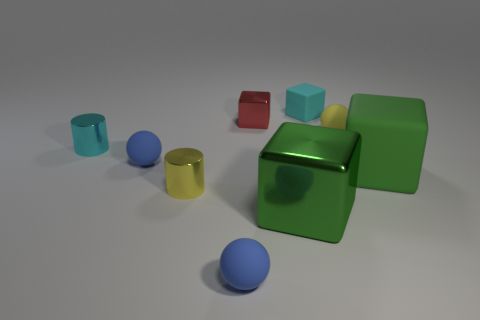Subtract all small blue matte spheres. How many spheres are left? 1 Add 1 small yellow matte things. How many objects exist? 10 Subtract 1 cylinders. How many cylinders are left? 1 Subtract all blue spheres. How many spheres are left? 1 Subtract 0 red cylinders. How many objects are left? 9 Subtract all cylinders. How many objects are left? 7 Subtract all blue blocks. Subtract all red spheres. How many blocks are left? 4 Subtract all gray balls. How many green cubes are left? 2 Subtract all small red shiny cubes. Subtract all red objects. How many objects are left? 7 Add 3 tiny cyan blocks. How many tiny cyan blocks are left? 4 